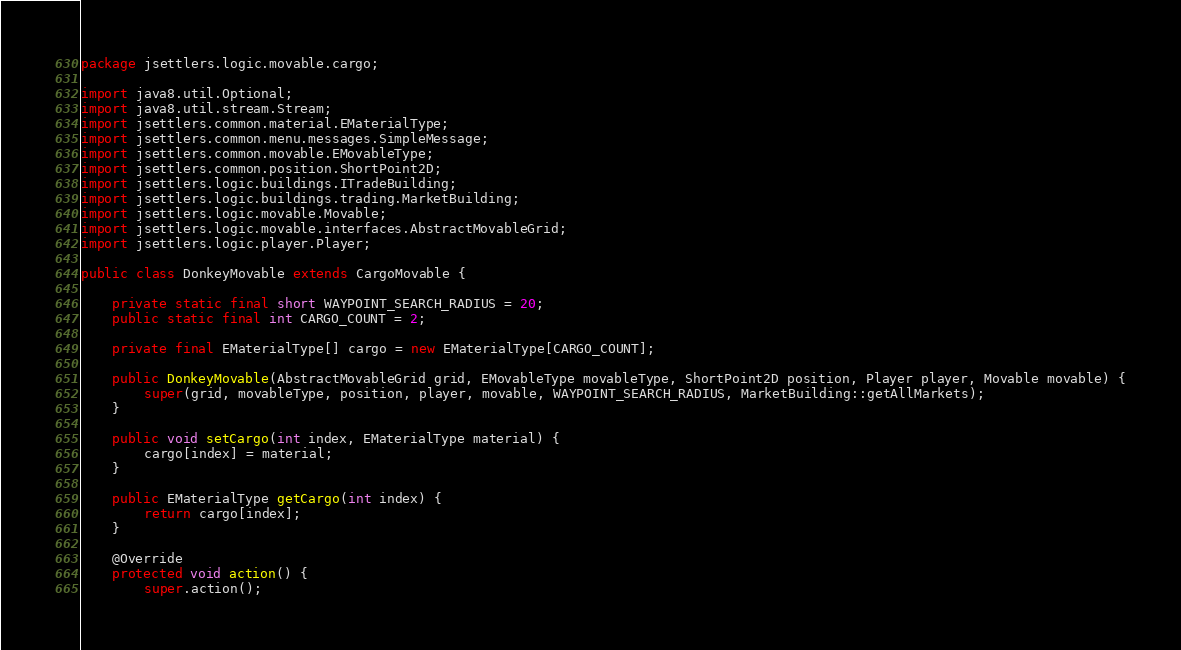Convert code to text. <code><loc_0><loc_0><loc_500><loc_500><_Java_>package jsettlers.logic.movable.cargo;

import java8.util.Optional;
import java8.util.stream.Stream;
import jsettlers.common.material.EMaterialType;
import jsettlers.common.menu.messages.SimpleMessage;
import jsettlers.common.movable.EMovableType;
import jsettlers.common.position.ShortPoint2D;
import jsettlers.logic.buildings.ITradeBuilding;
import jsettlers.logic.buildings.trading.MarketBuilding;
import jsettlers.logic.movable.Movable;
import jsettlers.logic.movable.interfaces.AbstractMovableGrid;
import jsettlers.logic.player.Player;

public class DonkeyMovable extends CargoMovable {

	private static final short WAYPOINT_SEARCH_RADIUS = 20;
	public static final int CARGO_COUNT = 2;

	private final EMaterialType[] cargo = new EMaterialType[CARGO_COUNT];

	public DonkeyMovable(AbstractMovableGrid grid, EMovableType movableType, ShortPoint2D position, Player player, Movable movable) {
		super(grid, movableType, position, player, movable, WAYPOINT_SEARCH_RADIUS, MarketBuilding::getAllMarkets);
	}

	public void setCargo(int index, EMaterialType material) {
		cargo[index] = material;
	}

	public EMaterialType getCargo(int index) {
		return cargo[index];
	}

	@Override
	protected void action() {
		super.action();
</code> 